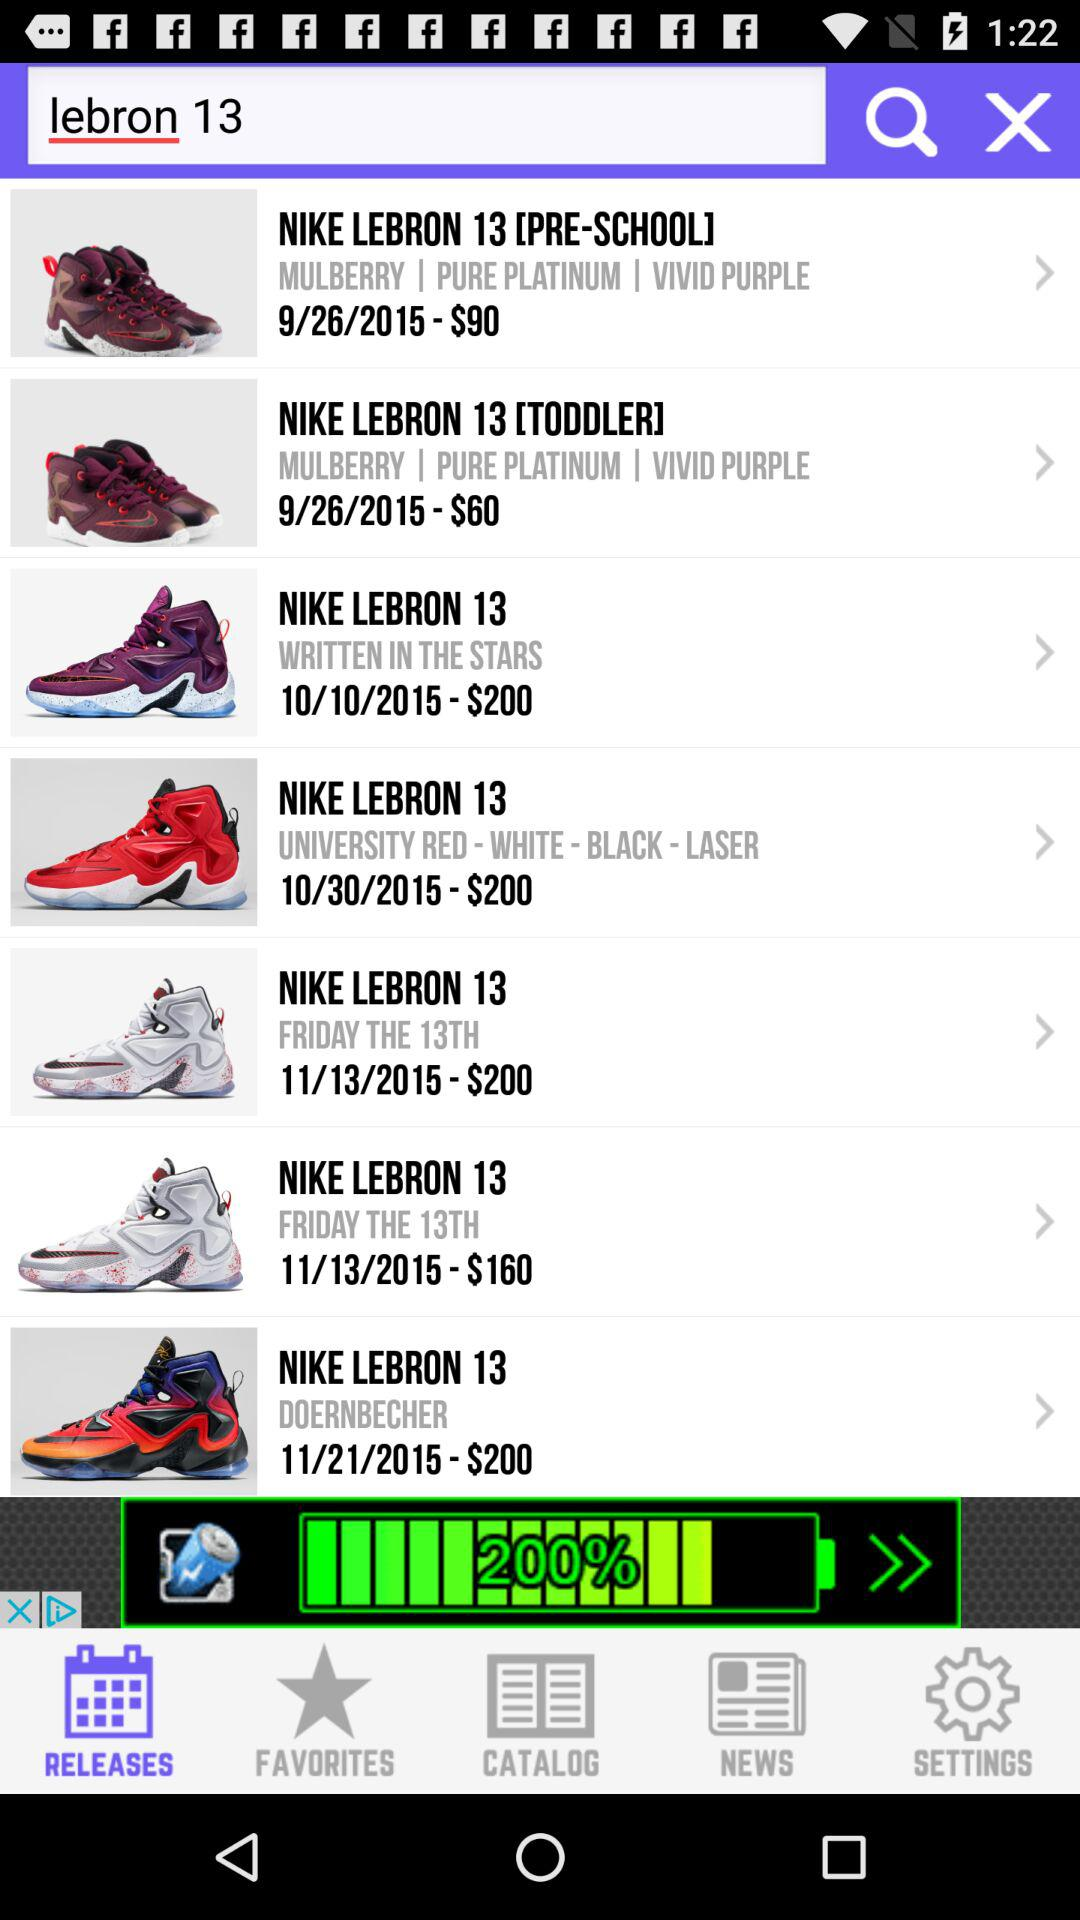How much is the "NIKE LEBRON 13 [TODDLER]"?
When the provided information is insufficient, respond with <no answer>. <no answer> 